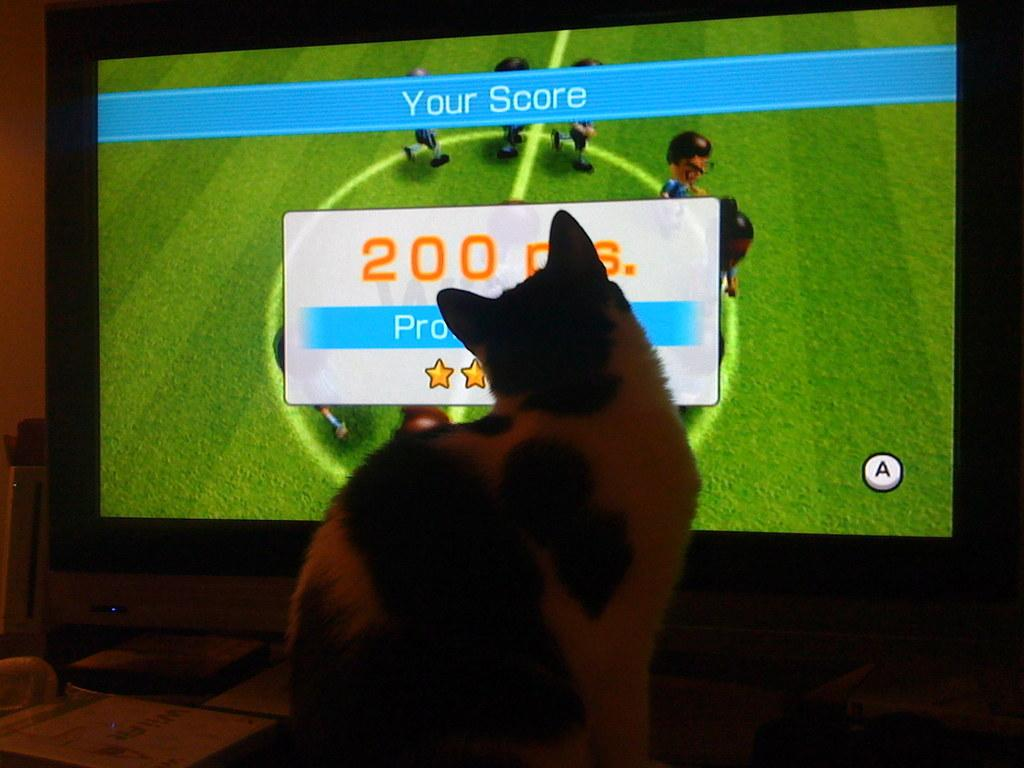What animal is present in the image? There is a cat in the image. Where is the cat located? The cat is sitting on a table. What is the cat looking at? The cat is looking at a TV. What type of cherries does the cat desire in the image? There are no cherries present in the image, and the cat's desires cannot be determined from the image. 